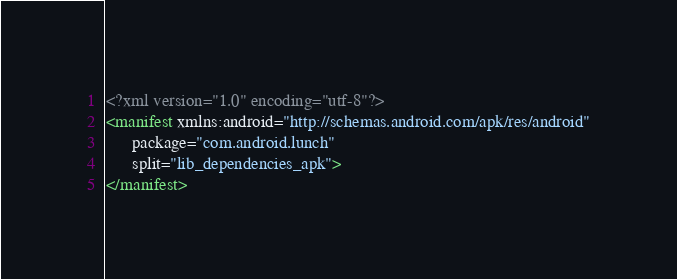<code> <loc_0><loc_0><loc_500><loc_500><_XML_><?xml version="1.0" encoding="utf-8"?>
<manifest xmlns:android="http://schemas.android.com/apk/res/android"
      package="com.android.lunch"
      split="lib_dependencies_apk">
</manifest>
</code> 